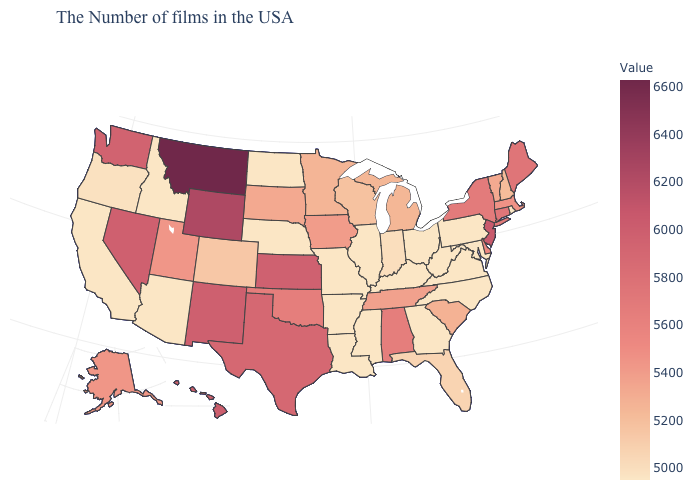Is the legend a continuous bar?
Short answer required. Yes. Which states have the lowest value in the MidWest?
Quick response, please. Ohio, Illinois, Missouri, Nebraska, North Dakota. Does Montana have the highest value in the USA?
Give a very brief answer. Yes. Which states hav the highest value in the Northeast?
Concise answer only. New Jersey. Among the states that border Pennsylvania , does Delaware have the lowest value?
Quick response, please. No. 